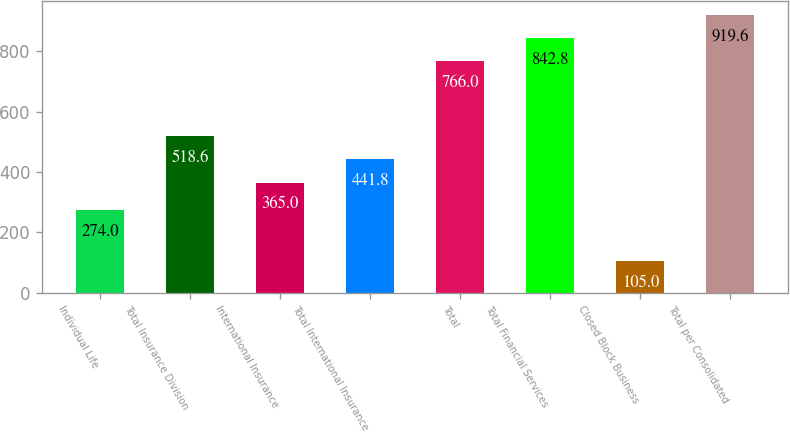Convert chart to OTSL. <chart><loc_0><loc_0><loc_500><loc_500><bar_chart><fcel>Individual Life<fcel>Total Insurance Division<fcel>International Insurance<fcel>Total International Insurance<fcel>Total<fcel>Total Financial Services<fcel>Closed Block Business<fcel>Total per Consolidated<nl><fcel>274<fcel>518.6<fcel>365<fcel>441.8<fcel>766<fcel>842.8<fcel>105<fcel>919.6<nl></chart> 